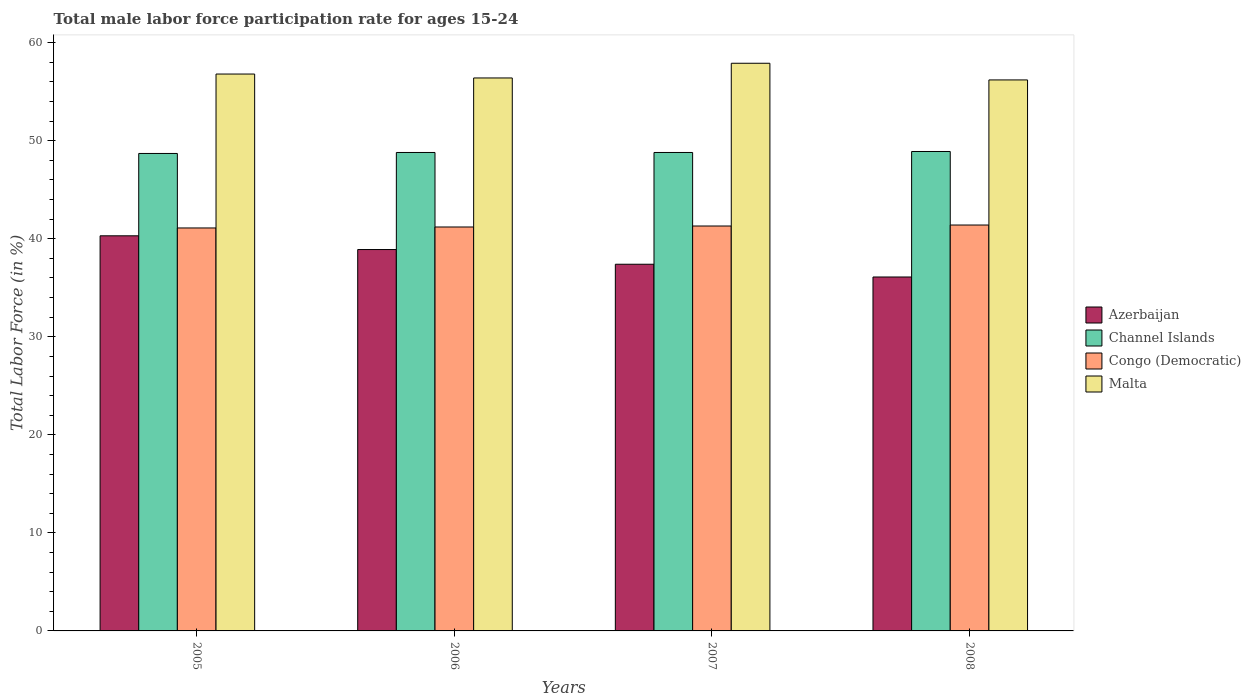How many different coloured bars are there?
Your answer should be compact. 4. Are the number of bars on each tick of the X-axis equal?
Give a very brief answer. Yes. What is the label of the 4th group of bars from the left?
Your answer should be very brief. 2008. What is the male labor force participation rate in Congo (Democratic) in 2005?
Offer a terse response. 41.1. Across all years, what is the maximum male labor force participation rate in Channel Islands?
Give a very brief answer. 48.9. Across all years, what is the minimum male labor force participation rate in Channel Islands?
Offer a very short reply. 48.7. In which year was the male labor force participation rate in Congo (Democratic) minimum?
Provide a succinct answer. 2005. What is the total male labor force participation rate in Azerbaijan in the graph?
Offer a terse response. 152.7. What is the difference between the male labor force participation rate in Congo (Democratic) in 2006 and that in 2007?
Offer a very short reply. -0.1. What is the difference between the male labor force participation rate in Congo (Democratic) in 2007 and the male labor force participation rate in Azerbaijan in 2006?
Offer a very short reply. 2.4. What is the average male labor force participation rate in Malta per year?
Your response must be concise. 56.83. In the year 2006, what is the difference between the male labor force participation rate in Malta and male labor force participation rate in Channel Islands?
Ensure brevity in your answer.  7.6. What is the ratio of the male labor force participation rate in Congo (Democratic) in 2005 to that in 2007?
Your answer should be compact. 1. Is the male labor force participation rate in Congo (Democratic) in 2005 less than that in 2006?
Keep it short and to the point. Yes. What is the difference between the highest and the second highest male labor force participation rate in Malta?
Your answer should be very brief. 1.1. What is the difference between the highest and the lowest male labor force participation rate in Azerbaijan?
Keep it short and to the point. 4.2. In how many years, is the male labor force participation rate in Congo (Democratic) greater than the average male labor force participation rate in Congo (Democratic) taken over all years?
Make the answer very short. 2. Is it the case that in every year, the sum of the male labor force participation rate in Azerbaijan and male labor force participation rate in Malta is greater than the sum of male labor force participation rate in Channel Islands and male labor force participation rate in Congo (Democratic)?
Offer a very short reply. No. What does the 1st bar from the left in 2007 represents?
Provide a succinct answer. Azerbaijan. What does the 4th bar from the right in 2005 represents?
Provide a short and direct response. Azerbaijan. Is it the case that in every year, the sum of the male labor force participation rate in Congo (Democratic) and male labor force participation rate in Azerbaijan is greater than the male labor force participation rate in Channel Islands?
Give a very brief answer. Yes. How many bars are there?
Offer a very short reply. 16. Does the graph contain any zero values?
Your answer should be compact. No. How many legend labels are there?
Your answer should be compact. 4. How are the legend labels stacked?
Give a very brief answer. Vertical. What is the title of the graph?
Your answer should be compact. Total male labor force participation rate for ages 15-24. What is the Total Labor Force (in %) in Azerbaijan in 2005?
Your response must be concise. 40.3. What is the Total Labor Force (in %) of Channel Islands in 2005?
Provide a succinct answer. 48.7. What is the Total Labor Force (in %) in Congo (Democratic) in 2005?
Your response must be concise. 41.1. What is the Total Labor Force (in %) of Malta in 2005?
Provide a succinct answer. 56.8. What is the Total Labor Force (in %) of Azerbaijan in 2006?
Keep it short and to the point. 38.9. What is the Total Labor Force (in %) of Channel Islands in 2006?
Provide a short and direct response. 48.8. What is the Total Labor Force (in %) in Congo (Democratic) in 2006?
Provide a succinct answer. 41.2. What is the Total Labor Force (in %) in Malta in 2006?
Your answer should be very brief. 56.4. What is the Total Labor Force (in %) of Azerbaijan in 2007?
Provide a succinct answer. 37.4. What is the Total Labor Force (in %) in Channel Islands in 2007?
Provide a short and direct response. 48.8. What is the Total Labor Force (in %) of Congo (Democratic) in 2007?
Ensure brevity in your answer.  41.3. What is the Total Labor Force (in %) in Malta in 2007?
Offer a very short reply. 57.9. What is the Total Labor Force (in %) in Azerbaijan in 2008?
Ensure brevity in your answer.  36.1. What is the Total Labor Force (in %) in Channel Islands in 2008?
Offer a terse response. 48.9. What is the Total Labor Force (in %) in Congo (Democratic) in 2008?
Your response must be concise. 41.4. What is the Total Labor Force (in %) in Malta in 2008?
Ensure brevity in your answer.  56.2. Across all years, what is the maximum Total Labor Force (in %) of Azerbaijan?
Your answer should be very brief. 40.3. Across all years, what is the maximum Total Labor Force (in %) of Channel Islands?
Your response must be concise. 48.9. Across all years, what is the maximum Total Labor Force (in %) in Congo (Democratic)?
Your response must be concise. 41.4. Across all years, what is the maximum Total Labor Force (in %) in Malta?
Your response must be concise. 57.9. Across all years, what is the minimum Total Labor Force (in %) of Azerbaijan?
Give a very brief answer. 36.1. Across all years, what is the minimum Total Labor Force (in %) in Channel Islands?
Make the answer very short. 48.7. Across all years, what is the minimum Total Labor Force (in %) in Congo (Democratic)?
Give a very brief answer. 41.1. Across all years, what is the minimum Total Labor Force (in %) of Malta?
Ensure brevity in your answer.  56.2. What is the total Total Labor Force (in %) of Azerbaijan in the graph?
Provide a short and direct response. 152.7. What is the total Total Labor Force (in %) in Channel Islands in the graph?
Your answer should be very brief. 195.2. What is the total Total Labor Force (in %) in Congo (Democratic) in the graph?
Make the answer very short. 165. What is the total Total Labor Force (in %) of Malta in the graph?
Offer a very short reply. 227.3. What is the difference between the Total Labor Force (in %) of Azerbaijan in 2005 and that in 2006?
Your response must be concise. 1.4. What is the difference between the Total Labor Force (in %) in Channel Islands in 2005 and that in 2007?
Offer a very short reply. -0.1. What is the difference between the Total Labor Force (in %) of Congo (Democratic) in 2005 and that in 2007?
Make the answer very short. -0.2. What is the difference between the Total Labor Force (in %) of Azerbaijan in 2005 and that in 2008?
Give a very brief answer. 4.2. What is the difference between the Total Labor Force (in %) in Channel Islands in 2005 and that in 2008?
Your answer should be very brief. -0.2. What is the difference between the Total Labor Force (in %) in Congo (Democratic) in 2005 and that in 2008?
Keep it short and to the point. -0.3. What is the difference between the Total Labor Force (in %) in Azerbaijan in 2006 and that in 2007?
Provide a succinct answer. 1.5. What is the difference between the Total Labor Force (in %) in Congo (Democratic) in 2006 and that in 2007?
Offer a terse response. -0.1. What is the difference between the Total Labor Force (in %) in Azerbaijan in 2006 and that in 2008?
Keep it short and to the point. 2.8. What is the difference between the Total Labor Force (in %) of Congo (Democratic) in 2006 and that in 2008?
Offer a very short reply. -0.2. What is the difference between the Total Labor Force (in %) in Channel Islands in 2007 and that in 2008?
Keep it short and to the point. -0.1. What is the difference between the Total Labor Force (in %) in Congo (Democratic) in 2007 and that in 2008?
Provide a short and direct response. -0.1. What is the difference between the Total Labor Force (in %) in Malta in 2007 and that in 2008?
Make the answer very short. 1.7. What is the difference between the Total Labor Force (in %) of Azerbaijan in 2005 and the Total Labor Force (in %) of Channel Islands in 2006?
Your answer should be very brief. -8.5. What is the difference between the Total Labor Force (in %) in Azerbaijan in 2005 and the Total Labor Force (in %) in Congo (Democratic) in 2006?
Keep it short and to the point. -0.9. What is the difference between the Total Labor Force (in %) of Azerbaijan in 2005 and the Total Labor Force (in %) of Malta in 2006?
Offer a very short reply. -16.1. What is the difference between the Total Labor Force (in %) of Congo (Democratic) in 2005 and the Total Labor Force (in %) of Malta in 2006?
Your answer should be compact. -15.3. What is the difference between the Total Labor Force (in %) in Azerbaijan in 2005 and the Total Labor Force (in %) in Channel Islands in 2007?
Ensure brevity in your answer.  -8.5. What is the difference between the Total Labor Force (in %) in Azerbaijan in 2005 and the Total Labor Force (in %) in Malta in 2007?
Provide a short and direct response. -17.6. What is the difference between the Total Labor Force (in %) in Channel Islands in 2005 and the Total Labor Force (in %) in Malta in 2007?
Keep it short and to the point. -9.2. What is the difference between the Total Labor Force (in %) of Congo (Democratic) in 2005 and the Total Labor Force (in %) of Malta in 2007?
Your answer should be compact. -16.8. What is the difference between the Total Labor Force (in %) in Azerbaijan in 2005 and the Total Labor Force (in %) in Channel Islands in 2008?
Provide a succinct answer. -8.6. What is the difference between the Total Labor Force (in %) in Azerbaijan in 2005 and the Total Labor Force (in %) in Malta in 2008?
Your answer should be very brief. -15.9. What is the difference between the Total Labor Force (in %) of Congo (Democratic) in 2005 and the Total Labor Force (in %) of Malta in 2008?
Make the answer very short. -15.1. What is the difference between the Total Labor Force (in %) of Azerbaijan in 2006 and the Total Labor Force (in %) of Malta in 2007?
Offer a terse response. -19. What is the difference between the Total Labor Force (in %) in Channel Islands in 2006 and the Total Labor Force (in %) in Congo (Democratic) in 2007?
Make the answer very short. 7.5. What is the difference between the Total Labor Force (in %) of Congo (Democratic) in 2006 and the Total Labor Force (in %) of Malta in 2007?
Make the answer very short. -16.7. What is the difference between the Total Labor Force (in %) in Azerbaijan in 2006 and the Total Labor Force (in %) in Channel Islands in 2008?
Make the answer very short. -10. What is the difference between the Total Labor Force (in %) in Azerbaijan in 2006 and the Total Labor Force (in %) in Congo (Democratic) in 2008?
Your answer should be very brief. -2.5. What is the difference between the Total Labor Force (in %) of Azerbaijan in 2006 and the Total Labor Force (in %) of Malta in 2008?
Provide a short and direct response. -17.3. What is the difference between the Total Labor Force (in %) in Channel Islands in 2006 and the Total Labor Force (in %) in Congo (Democratic) in 2008?
Your answer should be very brief. 7.4. What is the difference between the Total Labor Force (in %) of Channel Islands in 2006 and the Total Labor Force (in %) of Malta in 2008?
Your response must be concise. -7.4. What is the difference between the Total Labor Force (in %) in Azerbaijan in 2007 and the Total Labor Force (in %) in Congo (Democratic) in 2008?
Keep it short and to the point. -4. What is the difference between the Total Labor Force (in %) in Azerbaijan in 2007 and the Total Labor Force (in %) in Malta in 2008?
Offer a terse response. -18.8. What is the difference between the Total Labor Force (in %) in Channel Islands in 2007 and the Total Labor Force (in %) in Congo (Democratic) in 2008?
Offer a terse response. 7.4. What is the difference between the Total Labor Force (in %) of Channel Islands in 2007 and the Total Labor Force (in %) of Malta in 2008?
Offer a terse response. -7.4. What is the difference between the Total Labor Force (in %) of Congo (Democratic) in 2007 and the Total Labor Force (in %) of Malta in 2008?
Keep it short and to the point. -14.9. What is the average Total Labor Force (in %) of Azerbaijan per year?
Give a very brief answer. 38.17. What is the average Total Labor Force (in %) in Channel Islands per year?
Provide a succinct answer. 48.8. What is the average Total Labor Force (in %) of Congo (Democratic) per year?
Provide a succinct answer. 41.25. What is the average Total Labor Force (in %) of Malta per year?
Offer a very short reply. 56.83. In the year 2005, what is the difference between the Total Labor Force (in %) in Azerbaijan and Total Labor Force (in %) in Congo (Democratic)?
Provide a short and direct response. -0.8. In the year 2005, what is the difference between the Total Labor Force (in %) of Azerbaijan and Total Labor Force (in %) of Malta?
Keep it short and to the point. -16.5. In the year 2005, what is the difference between the Total Labor Force (in %) in Channel Islands and Total Labor Force (in %) in Malta?
Provide a succinct answer. -8.1. In the year 2005, what is the difference between the Total Labor Force (in %) in Congo (Democratic) and Total Labor Force (in %) in Malta?
Make the answer very short. -15.7. In the year 2006, what is the difference between the Total Labor Force (in %) in Azerbaijan and Total Labor Force (in %) in Malta?
Make the answer very short. -17.5. In the year 2006, what is the difference between the Total Labor Force (in %) of Congo (Democratic) and Total Labor Force (in %) of Malta?
Make the answer very short. -15.2. In the year 2007, what is the difference between the Total Labor Force (in %) in Azerbaijan and Total Labor Force (in %) in Congo (Democratic)?
Offer a very short reply. -3.9. In the year 2007, what is the difference between the Total Labor Force (in %) in Azerbaijan and Total Labor Force (in %) in Malta?
Provide a short and direct response. -20.5. In the year 2007, what is the difference between the Total Labor Force (in %) in Channel Islands and Total Labor Force (in %) in Congo (Democratic)?
Offer a terse response. 7.5. In the year 2007, what is the difference between the Total Labor Force (in %) in Congo (Democratic) and Total Labor Force (in %) in Malta?
Keep it short and to the point. -16.6. In the year 2008, what is the difference between the Total Labor Force (in %) of Azerbaijan and Total Labor Force (in %) of Congo (Democratic)?
Offer a very short reply. -5.3. In the year 2008, what is the difference between the Total Labor Force (in %) in Azerbaijan and Total Labor Force (in %) in Malta?
Offer a very short reply. -20.1. In the year 2008, what is the difference between the Total Labor Force (in %) in Congo (Democratic) and Total Labor Force (in %) in Malta?
Give a very brief answer. -14.8. What is the ratio of the Total Labor Force (in %) in Azerbaijan in 2005 to that in 2006?
Provide a short and direct response. 1.04. What is the ratio of the Total Labor Force (in %) of Channel Islands in 2005 to that in 2006?
Your response must be concise. 1. What is the ratio of the Total Labor Force (in %) of Malta in 2005 to that in 2006?
Your response must be concise. 1.01. What is the ratio of the Total Labor Force (in %) of Azerbaijan in 2005 to that in 2007?
Your response must be concise. 1.08. What is the ratio of the Total Labor Force (in %) of Congo (Democratic) in 2005 to that in 2007?
Offer a very short reply. 1. What is the ratio of the Total Labor Force (in %) of Azerbaijan in 2005 to that in 2008?
Ensure brevity in your answer.  1.12. What is the ratio of the Total Labor Force (in %) of Malta in 2005 to that in 2008?
Give a very brief answer. 1.01. What is the ratio of the Total Labor Force (in %) of Azerbaijan in 2006 to that in 2007?
Provide a succinct answer. 1.04. What is the ratio of the Total Labor Force (in %) in Congo (Democratic) in 2006 to that in 2007?
Offer a very short reply. 1. What is the ratio of the Total Labor Force (in %) in Malta in 2006 to that in 2007?
Make the answer very short. 0.97. What is the ratio of the Total Labor Force (in %) of Azerbaijan in 2006 to that in 2008?
Offer a very short reply. 1.08. What is the ratio of the Total Labor Force (in %) of Congo (Democratic) in 2006 to that in 2008?
Keep it short and to the point. 1. What is the ratio of the Total Labor Force (in %) of Malta in 2006 to that in 2008?
Provide a succinct answer. 1. What is the ratio of the Total Labor Force (in %) in Azerbaijan in 2007 to that in 2008?
Offer a terse response. 1.04. What is the ratio of the Total Labor Force (in %) in Channel Islands in 2007 to that in 2008?
Provide a succinct answer. 1. What is the ratio of the Total Labor Force (in %) of Malta in 2007 to that in 2008?
Your response must be concise. 1.03. What is the difference between the highest and the second highest Total Labor Force (in %) of Azerbaijan?
Offer a terse response. 1.4. What is the difference between the highest and the lowest Total Labor Force (in %) in Channel Islands?
Make the answer very short. 0.2. What is the difference between the highest and the lowest Total Labor Force (in %) in Malta?
Offer a terse response. 1.7. 